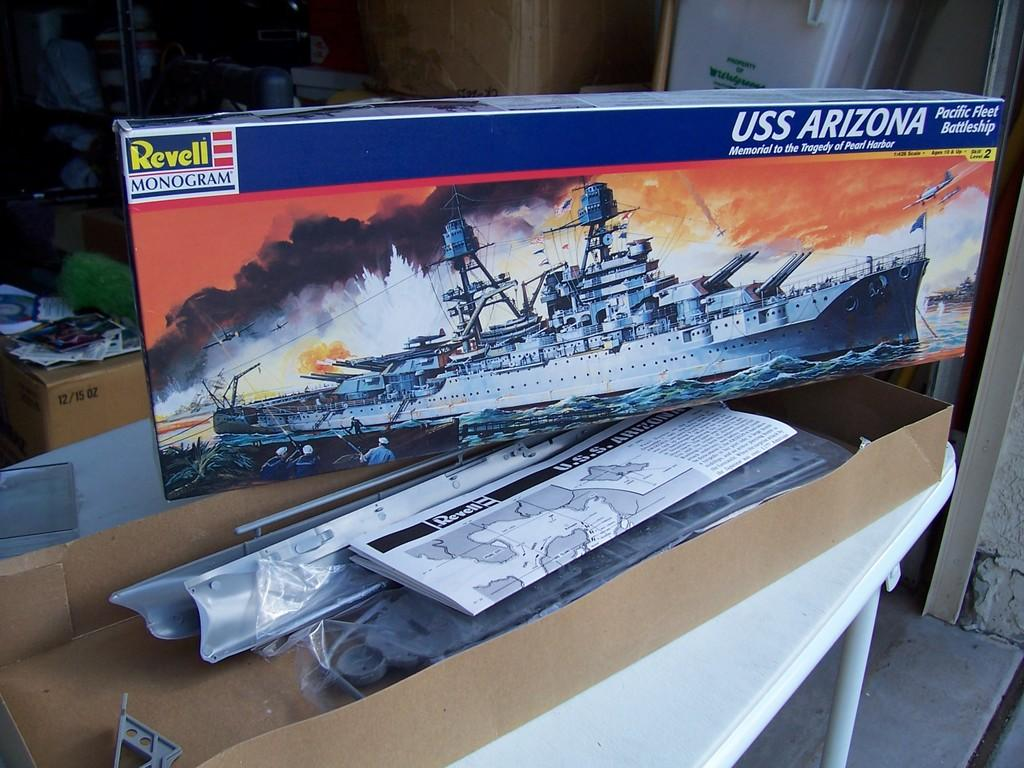What type of containers are present in the image? There are cardboard boxes in the image. What else can be seen in the image besides the cardboard boxes? There are papers visible in the image. What piece of furniture is present in the image? There is a table in the image. What can be seen in the background of the image? There are objects visible in the background of the image. What type of earth can be seen in the image? There is no earth visible in the image; it is an indoor scene with cardboard boxes, papers, and a table. 